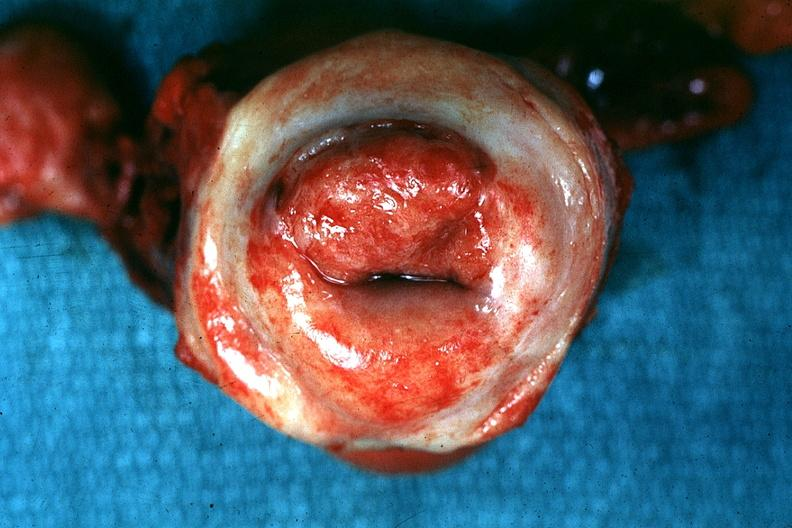where does this belong to?
Answer the question using a single word or phrase. Female reproductive system 